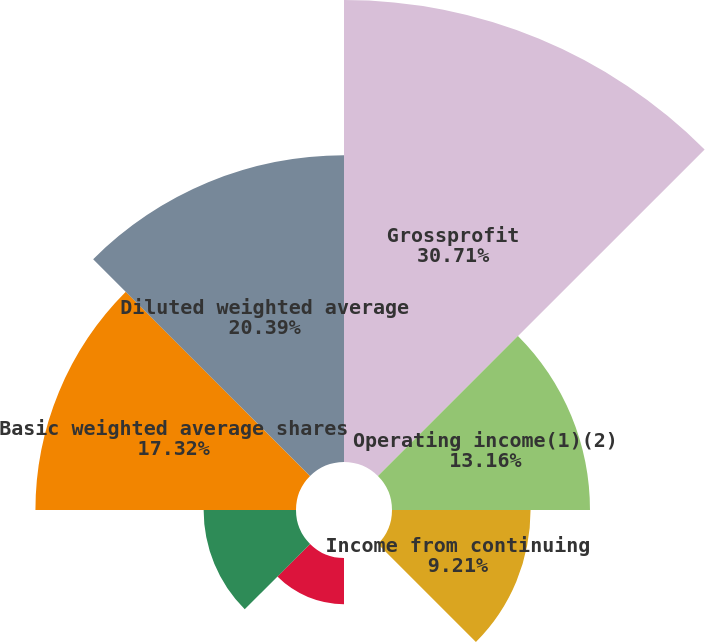Convert chart to OTSL. <chart><loc_0><loc_0><loc_500><loc_500><pie_chart><fcel>Grossprofit<fcel>Operating income(1)(2)<fcel>Income from continuing<fcel>Basic EPS from continuing<fcel>BasicEPS<fcel>Diluted EPS from continuing<fcel>Basic weighted average shares<fcel>Diluted weighted average<nl><fcel>30.71%<fcel>13.16%<fcel>9.21%<fcel>0.0%<fcel>3.07%<fcel>6.14%<fcel>17.32%<fcel>20.39%<nl></chart> 